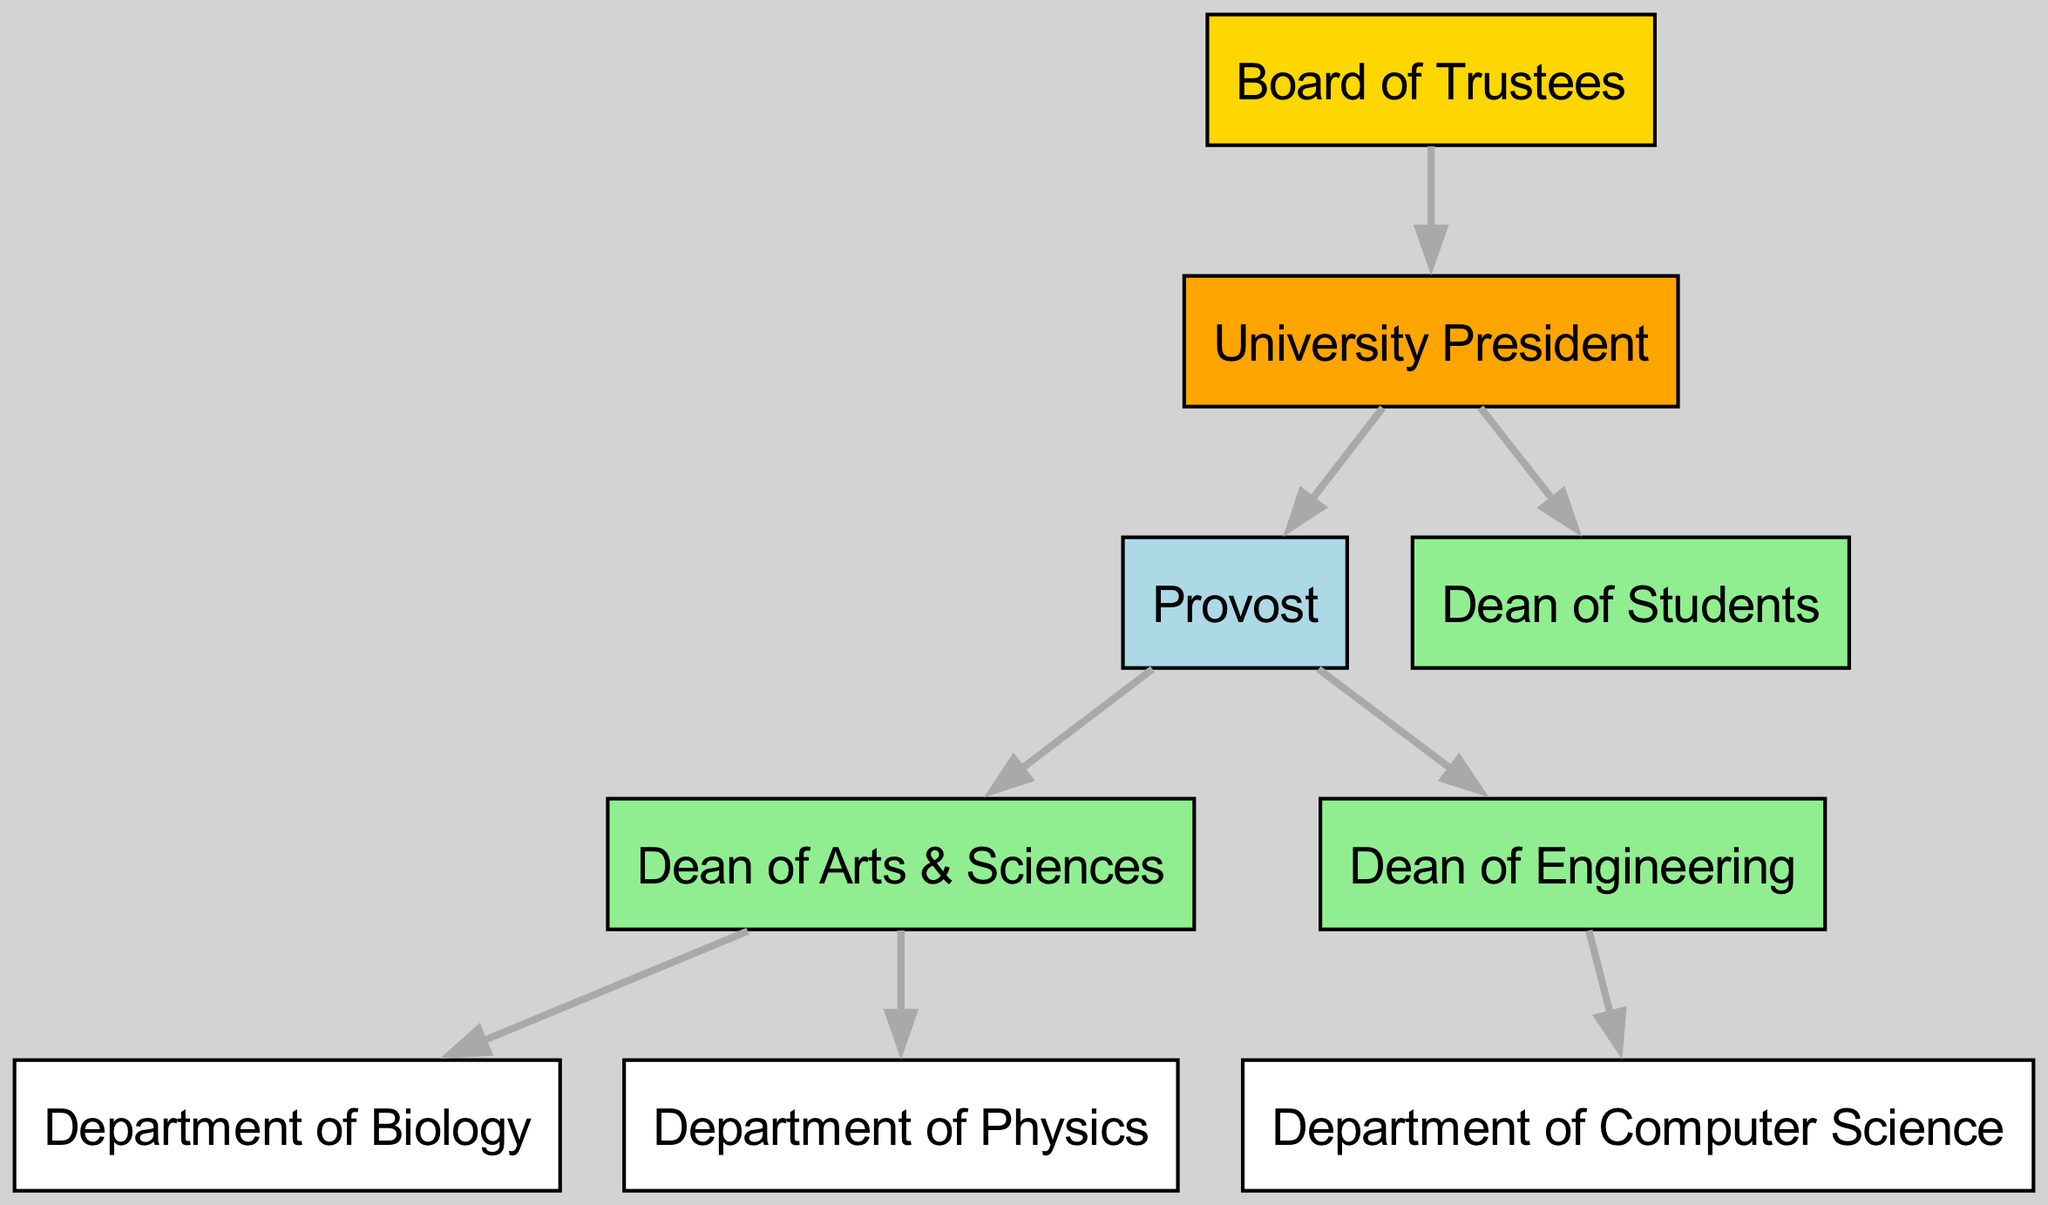What is the highest authority in this organizational structure? The highest authority represented in the diagram is the Board of Trustees, which is positioned at the top of the hierarchical organizational chart.
Answer: Board of Trustees How many deans are present in the diagram? Counting the nodes labeled as deans, there are three: the Dean of Students, the Dean of Arts & Sciences, and the Dean of Engineering.
Answer: 3 Which node is directly below the University President? The University President has two direct reports in the diagram: the Provost and the Dean of Students. Both nodes are directly connected below the President.
Answer: Provost and Dean of Students Which department is under the Dean of Arts & Sciences? The Dean of Arts & Sciences oversees both the Department of Biology and the Department of Physics, as indicated by the connections in the organizational chart.
Answer: Department of Biology and Department of Physics What color represents the Provost in the diagram? The Provost is represented by a light blue color in the diagram, which visually differentiates this role from others.
Answer: Light blue Which department is governed by the Dean of Engineering? The Dean of Engineering supervises only the Department of Computer Science, as shown by the directed edge connecting them in the diagram.
Answer: Department of Computer Science What is the relationship between the Board of Trustees and the University President? The relationship represented is hierarchical, where the Board of Trustees is the highest governing body and directly appoints the University President, as indicated by the directed edge from the Board to the President.
Answer: Appoints How many edges are there in total within the diagram? By counting the edges, which represent relationships between nodes, we find there are eight edges depicted in the organizational chart.
Answer: 8 What is the significance of the hierarchical arrangement in this diagram? The hierarchical arrangement allows for clarity in the organizational structure, showing clear lines of authority and reporting relationships, essential for understanding how governance and administration flow in a university setting.
Answer: Clarity of authority Which position oversees multiple departments? The Dean of Arts & Sciences oversees multiple departments, specifically the Departments of Biology and Physics, as indicated by the outgoing connections from that node.
Answer: Dean of Arts & Sciences 